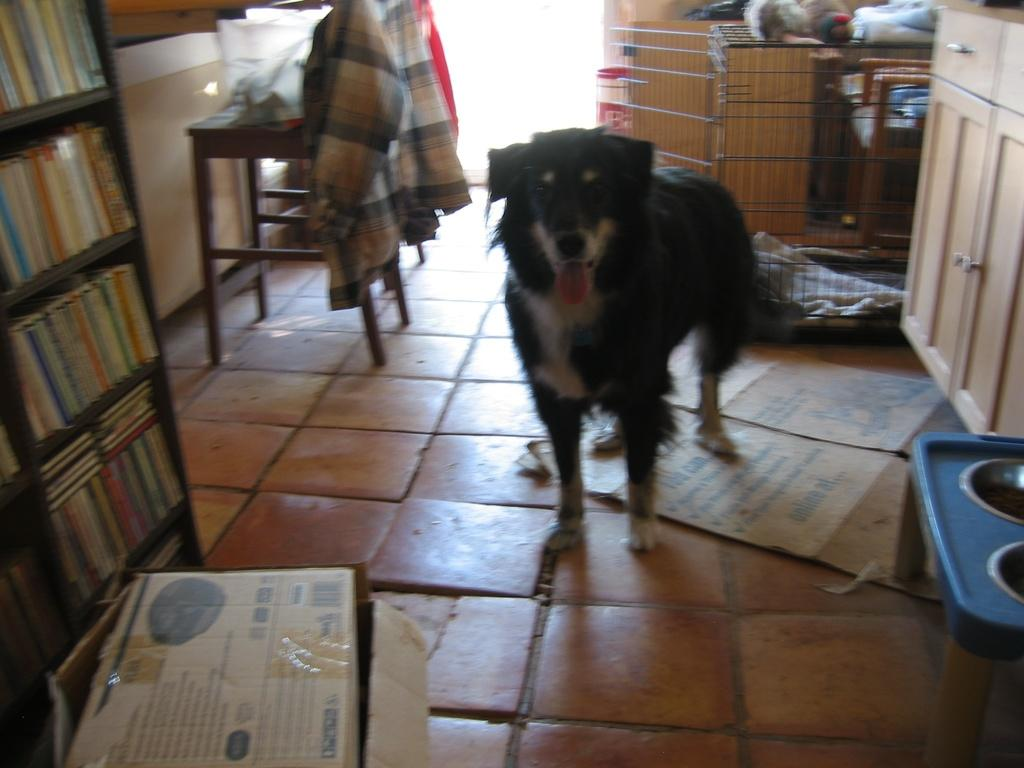What type of animal is present in the image? There is a dog in the image. What structure can be seen in the image that might be used for containing or housing something? There is a cage in the image. What object is present in the image that might be used for storage or transportation? There is a box in the image. What piece of furniture is present in the image? There is a table in the image. What type of item can be seen in the image that is typically used for learning or entertainment? There are multiple books in the image. How many bikes are present in the image? There are no bikes present in the image. What type of party is being held in the image? There is no party depicted in the image. 